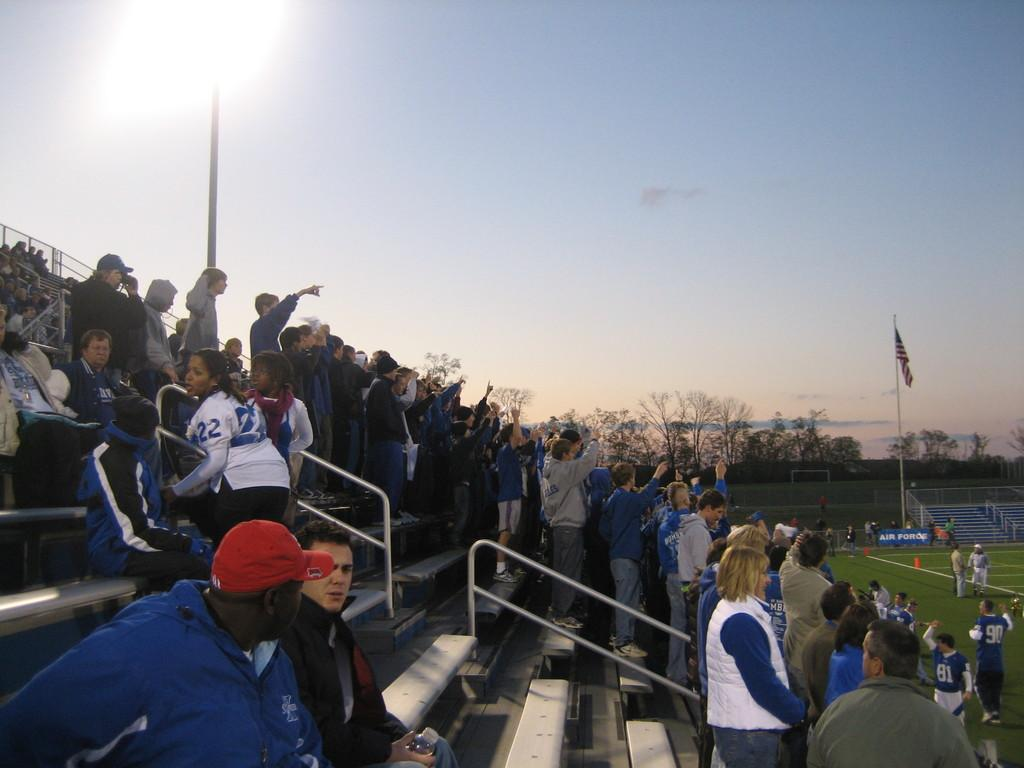What are the people in the image doing? There are people sitting and standing on the staircase, as well as standing on the ground. What can be seen on the flag post? There is a flag on the flag post. What safety feature is present in the image? There are railings in the image. What type of vegetation is visible in the image? There are trees visible in the image. What part of the natural environment is visible in the image? The sky is visible in the image. What type of fan is visible in the image? There is no fan present in the image. How many different types of sorting methods can be observed in the image? There is no sorting activity or method depicted in the image. 